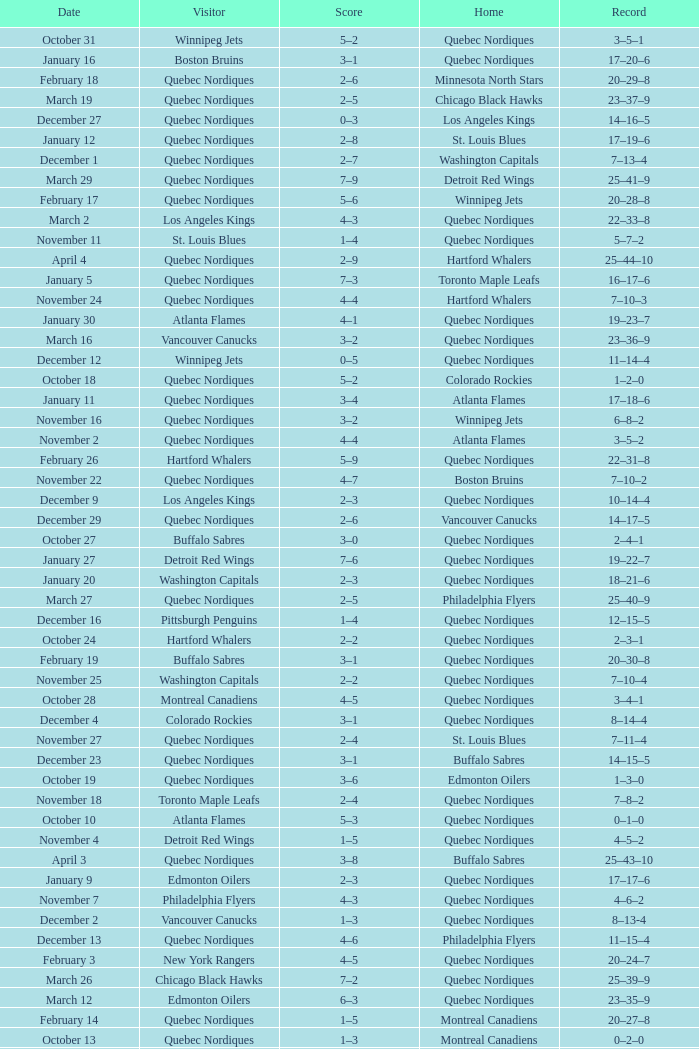Which Record has a Home of edmonton oilers, and a Score of 3–6? 1–3–0. 